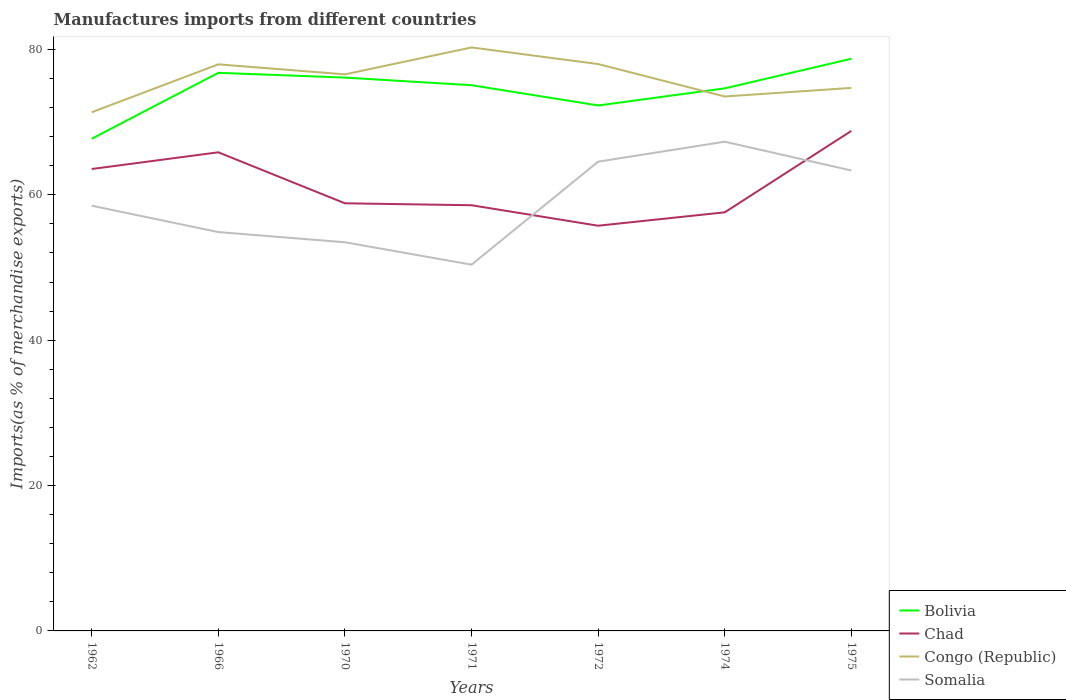Across all years, what is the maximum percentage of imports to different countries in Chad?
Offer a very short reply. 55.75. What is the total percentage of imports to different countries in Bolivia in the graph?
Make the answer very short. -2.59. What is the difference between the highest and the second highest percentage of imports to different countries in Bolivia?
Offer a terse response. 11. Is the percentage of imports to different countries in Bolivia strictly greater than the percentage of imports to different countries in Somalia over the years?
Your response must be concise. No. How many lines are there?
Offer a terse response. 4. What is the difference between two consecutive major ticks on the Y-axis?
Provide a succinct answer. 20. Does the graph contain grids?
Offer a terse response. No. Where does the legend appear in the graph?
Ensure brevity in your answer.  Bottom right. How many legend labels are there?
Make the answer very short. 4. How are the legend labels stacked?
Your answer should be compact. Vertical. What is the title of the graph?
Keep it short and to the point. Manufactures imports from different countries. Does "Cabo Verde" appear as one of the legend labels in the graph?
Provide a succinct answer. No. What is the label or title of the Y-axis?
Offer a very short reply. Imports(as % of merchandise exports). What is the Imports(as % of merchandise exports) of Bolivia in 1962?
Provide a short and direct response. 67.72. What is the Imports(as % of merchandise exports) of Chad in 1962?
Offer a very short reply. 63.55. What is the Imports(as % of merchandise exports) of Congo (Republic) in 1962?
Make the answer very short. 71.36. What is the Imports(as % of merchandise exports) of Somalia in 1962?
Give a very brief answer. 58.51. What is the Imports(as % of merchandise exports) of Bolivia in 1966?
Provide a succinct answer. 76.79. What is the Imports(as % of merchandise exports) of Chad in 1966?
Give a very brief answer. 65.85. What is the Imports(as % of merchandise exports) in Congo (Republic) in 1966?
Provide a short and direct response. 77.95. What is the Imports(as % of merchandise exports) in Somalia in 1966?
Offer a very short reply. 54.88. What is the Imports(as % of merchandise exports) in Bolivia in 1970?
Provide a short and direct response. 76.13. What is the Imports(as % of merchandise exports) of Chad in 1970?
Your response must be concise. 58.84. What is the Imports(as % of merchandise exports) in Congo (Republic) in 1970?
Your answer should be very brief. 76.58. What is the Imports(as % of merchandise exports) in Somalia in 1970?
Provide a succinct answer. 53.47. What is the Imports(as % of merchandise exports) in Bolivia in 1971?
Your answer should be compact. 75.09. What is the Imports(as % of merchandise exports) in Chad in 1971?
Give a very brief answer. 58.57. What is the Imports(as % of merchandise exports) in Congo (Republic) in 1971?
Your response must be concise. 80.28. What is the Imports(as % of merchandise exports) in Somalia in 1971?
Ensure brevity in your answer.  50.39. What is the Imports(as % of merchandise exports) in Bolivia in 1972?
Your response must be concise. 72.3. What is the Imports(as % of merchandise exports) of Chad in 1972?
Provide a succinct answer. 55.75. What is the Imports(as % of merchandise exports) of Congo (Republic) in 1972?
Your answer should be compact. 78. What is the Imports(as % of merchandise exports) of Somalia in 1972?
Provide a succinct answer. 64.56. What is the Imports(as % of merchandise exports) of Bolivia in 1974?
Provide a short and direct response. 74.65. What is the Imports(as % of merchandise exports) of Chad in 1974?
Your response must be concise. 57.59. What is the Imports(as % of merchandise exports) in Congo (Republic) in 1974?
Your answer should be compact. 73.53. What is the Imports(as % of merchandise exports) of Somalia in 1974?
Give a very brief answer. 67.31. What is the Imports(as % of merchandise exports) in Bolivia in 1975?
Your response must be concise. 78.73. What is the Imports(as % of merchandise exports) of Chad in 1975?
Your response must be concise. 68.8. What is the Imports(as % of merchandise exports) of Congo (Republic) in 1975?
Provide a succinct answer. 74.71. What is the Imports(as % of merchandise exports) in Somalia in 1975?
Your response must be concise. 63.35. Across all years, what is the maximum Imports(as % of merchandise exports) of Bolivia?
Keep it short and to the point. 78.73. Across all years, what is the maximum Imports(as % of merchandise exports) in Chad?
Your answer should be very brief. 68.8. Across all years, what is the maximum Imports(as % of merchandise exports) in Congo (Republic)?
Your answer should be compact. 80.28. Across all years, what is the maximum Imports(as % of merchandise exports) in Somalia?
Make the answer very short. 67.31. Across all years, what is the minimum Imports(as % of merchandise exports) of Bolivia?
Make the answer very short. 67.72. Across all years, what is the minimum Imports(as % of merchandise exports) of Chad?
Your answer should be compact. 55.75. Across all years, what is the minimum Imports(as % of merchandise exports) in Congo (Republic)?
Provide a short and direct response. 71.36. Across all years, what is the minimum Imports(as % of merchandise exports) in Somalia?
Provide a short and direct response. 50.39. What is the total Imports(as % of merchandise exports) of Bolivia in the graph?
Keep it short and to the point. 521.41. What is the total Imports(as % of merchandise exports) of Chad in the graph?
Give a very brief answer. 428.96. What is the total Imports(as % of merchandise exports) of Congo (Republic) in the graph?
Provide a short and direct response. 532.42. What is the total Imports(as % of merchandise exports) of Somalia in the graph?
Keep it short and to the point. 412.48. What is the difference between the Imports(as % of merchandise exports) in Bolivia in 1962 and that in 1966?
Your answer should be very brief. -9.07. What is the difference between the Imports(as % of merchandise exports) of Chad in 1962 and that in 1966?
Your answer should be compact. -2.3. What is the difference between the Imports(as % of merchandise exports) of Congo (Republic) in 1962 and that in 1966?
Your response must be concise. -6.59. What is the difference between the Imports(as % of merchandise exports) of Somalia in 1962 and that in 1966?
Keep it short and to the point. 3.63. What is the difference between the Imports(as % of merchandise exports) of Bolivia in 1962 and that in 1970?
Offer a terse response. -8.41. What is the difference between the Imports(as % of merchandise exports) in Chad in 1962 and that in 1970?
Ensure brevity in your answer.  4.72. What is the difference between the Imports(as % of merchandise exports) of Congo (Republic) in 1962 and that in 1970?
Keep it short and to the point. -5.22. What is the difference between the Imports(as % of merchandise exports) in Somalia in 1962 and that in 1970?
Ensure brevity in your answer.  5.03. What is the difference between the Imports(as % of merchandise exports) of Bolivia in 1962 and that in 1971?
Your answer should be compact. -7.36. What is the difference between the Imports(as % of merchandise exports) of Chad in 1962 and that in 1971?
Offer a very short reply. 4.98. What is the difference between the Imports(as % of merchandise exports) in Congo (Republic) in 1962 and that in 1971?
Provide a short and direct response. -8.92. What is the difference between the Imports(as % of merchandise exports) of Somalia in 1962 and that in 1971?
Offer a terse response. 8.12. What is the difference between the Imports(as % of merchandise exports) of Bolivia in 1962 and that in 1972?
Make the answer very short. -4.58. What is the difference between the Imports(as % of merchandise exports) of Chad in 1962 and that in 1972?
Your response must be concise. 7.8. What is the difference between the Imports(as % of merchandise exports) of Congo (Republic) in 1962 and that in 1972?
Your response must be concise. -6.63. What is the difference between the Imports(as % of merchandise exports) in Somalia in 1962 and that in 1972?
Your answer should be very brief. -6.06. What is the difference between the Imports(as % of merchandise exports) of Bolivia in 1962 and that in 1974?
Offer a terse response. -6.93. What is the difference between the Imports(as % of merchandise exports) in Chad in 1962 and that in 1974?
Provide a short and direct response. 5.96. What is the difference between the Imports(as % of merchandise exports) in Congo (Republic) in 1962 and that in 1974?
Your answer should be compact. -2.17. What is the difference between the Imports(as % of merchandise exports) in Somalia in 1962 and that in 1974?
Keep it short and to the point. -8.81. What is the difference between the Imports(as % of merchandise exports) of Bolivia in 1962 and that in 1975?
Keep it short and to the point. -11. What is the difference between the Imports(as % of merchandise exports) in Chad in 1962 and that in 1975?
Provide a succinct answer. -5.24. What is the difference between the Imports(as % of merchandise exports) of Congo (Republic) in 1962 and that in 1975?
Your answer should be very brief. -3.35. What is the difference between the Imports(as % of merchandise exports) of Somalia in 1962 and that in 1975?
Your answer should be very brief. -4.84. What is the difference between the Imports(as % of merchandise exports) of Bolivia in 1966 and that in 1970?
Your answer should be compact. 0.66. What is the difference between the Imports(as % of merchandise exports) in Chad in 1966 and that in 1970?
Ensure brevity in your answer.  7.02. What is the difference between the Imports(as % of merchandise exports) of Congo (Republic) in 1966 and that in 1970?
Keep it short and to the point. 1.38. What is the difference between the Imports(as % of merchandise exports) in Somalia in 1966 and that in 1970?
Ensure brevity in your answer.  1.4. What is the difference between the Imports(as % of merchandise exports) in Bolivia in 1966 and that in 1971?
Keep it short and to the point. 1.7. What is the difference between the Imports(as % of merchandise exports) of Chad in 1966 and that in 1971?
Make the answer very short. 7.28. What is the difference between the Imports(as % of merchandise exports) of Congo (Republic) in 1966 and that in 1971?
Give a very brief answer. -2.33. What is the difference between the Imports(as % of merchandise exports) of Somalia in 1966 and that in 1971?
Give a very brief answer. 4.49. What is the difference between the Imports(as % of merchandise exports) of Bolivia in 1966 and that in 1972?
Your answer should be compact. 4.49. What is the difference between the Imports(as % of merchandise exports) of Chad in 1966 and that in 1972?
Keep it short and to the point. 10.1. What is the difference between the Imports(as % of merchandise exports) in Congo (Republic) in 1966 and that in 1972?
Your answer should be compact. -0.04. What is the difference between the Imports(as % of merchandise exports) of Somalia in 1966 and that in 1972?
Your answer should be compact. -9.69. What is the difference between the Imports(as % of merchandise exports) in Bolivia in 1966 and that in 1974?
Your answer should be very brief. 2.14. What is the difference between the Imports(as % of merchandise exports) in Chad in 1966 and that in 1974?
Provide a succinct answer. 8.26. What is the difference between the Imports(as % of merchandise exports) of Congo (Republic) in 1966 and that in 1974?
Provide a succinct answer. 4.42. What is the difference between the Imports(as % of merchandise exports) in Somalia in 1966 and that in 1974?
Your answer should be compact. -12.44. What is the difference between the Imports(as % of merchandise exports) in Bolivia in 1966 and that in 1975?
Your response must be concise. -1.94. What is the difference between the Imports(as % of merchandise exports) of Chad in 1966 and that in 1975?
Provide a succinct answer. -2.94. What is the difference between the Imports(as % of merchandise exports) of Congo (Republic) in 1966 and that in 1975?
Offer a very short reply. 3.24. What is the difference between the Imports(as % of merchandise exports) in Somalia in 1966 and that in 1975?
Provide a short and direct response. -8.48. What is the difference between the Imports(as % of merchandise exports) in Bolivia in 1970 and that in 1971?
Offer a very short reply. 1.05. What is the difference between the Imports(as % of merchandise exports) in Chad in 1970 and that in 1971?
Provide a succinct answer. 0.27. What is the difference between the Imports(as % of merchandise exports) in Congo (Republic) in 1970 and that in 1971?
Keep it short and to the point. -3.7. What is the difference between the Imports(as % of merchandise exports) in Somalia in 1970 and that in 1971?
Your answer should be very brief. 3.08. What is the difference between the Imports(as % of merchandise exports) in Bolivia in 1970 and that in 1972?
Keep it short and to the point. 3.83. What is the difference between the Imports(as % of merchandise exports) in Chad in 1970 and that in 1972?
Keep it short and to the point. 3.08. What is the difference between the Imports(as % of merchandise exports) in Congo (Republic) in 1970 and that in 1972?
Make the answer very short. -1.42. What is the difference between the Imports(as % of merchandise exports) of Somalia in 1970 and that in 1972?
Your response must be concise. -11.09. What is the difference between the Imports(as % of merchandise exports) of Bolivia in 1970 and that in 1974?
Offer a terse response. 1.48. What is the difference between the Imports(as % of merchandise exports) of Chad in 1970 and that in 1974?
Give a very brief answer. 1.24. What is the difference between the Imports(as % of merchandise exports) in Congo (Republic) in 1970 and that in 1974?
Your response must be concise. 3.05. What is the difference between the Imports(as % of merchandise exports) of Somalia in 1970 and that in 1974?
Give a very brief answer. -13.84. What is the difference between the Imports(as % of merchandise exports) in Bolivia in 1970 and that in 1975?
Provide a short and direct response. -2.59. What is the difference between the Imports(as % of merchandise exports) of Chad in 1970 and that in 1975?
Offer a terse response. -9.96. What is the difference between the Imports(as % of merchandise exports) of Congo (Republic) in 1970 and that in 1975?
Provide a succinct answer. 1.86. What is the difference between the Imports(as % of merchandise exports) in Somalia in 1970 and that in 1975?
Offer a very short reply. -9.88. What is the difference between the Imports(as % of merchandise exports) in Bolivia in 1971 and that in 1972?
Make the answer very short. 2.79. What is the difference between the Imports(as % of merchandise exports) of Chad in 1971 and that in 1972?
Give a very brief answer. 2.82. What is the difference between the Imports(as % of merchandise exports) in Congo (Republic) in 1971 and that in 1972?
Provide a short and direct response. 2.29. What is the difference between the Imports(as % of merchandise exports) of Somalia in 1971 and that in 1972?
Your answer should be compact. -14.17. What is the difference between the Imports(as % of merchandise exports) in Bolivia in 1971 and that in 1974?
Make the answer very short. 0.43. What is the difference between the Imports(as % of merchandise exports) in Chad in 1971 and that in 1974?
Make the answer very short. 0.97. What is the difference between the Imports(as % of merchandise exports) in Congo (Republic) in 1971 and that in 1974?
Give a very brief answer. 6.75. What is the difference between the Imports(as % of merchandise exports) in Somalia in 1971 and that in 1974?
Your answer should be very brief. -16.92. What is the difference between the Imports(as % of merchandise exports) of Bolivia in 1971 and that in 1975?
Your answer should be compact. -3.64. What is the difference between the Imports(as % of merchandise exports) of Chad in 1971 and that in 1975?
Offer a very short reply. -10.23. What is the difference between the Imports(as % of merchandise exports) in Congo (Republic) in 1971 and that in 1975?
Offer a very short reply. 5.57. What is the difference between the Imports(as % of merchandise exports) in Somalia in 1971 and that in 1975?
Your answer should be very brief. -12.96. What is the difference between the Imports(as % of merchandise exports) in Bolivia in 1972 and that in 1974?
Ensure brevity in your answer.  -2.35. What is the difference between the Imports(as % of merchandise exports) in Chad in 1972 and that in 1974?
Provide a succinct answer. -1.84. What is the difference between the Imports(as % of merchandise exports) of Congo (Republic) in 1972 and that in 1974?
Offer a terse response. 4.46. What is the difference between the Imports(as % of merchandise exports) of Somalia in 1972 and that in 1974?
Ensure brevity in your answer.  -2.75. What is the difference between the Imports(as % of merchandise exports) of Bolivia in 1972 and that in 1975?
Ensure brevity in your answer.  -6.43. What is the difference between the Imports(as % of merchandise exports) of Chad in 1972 and that in 1975?
Offer a terse response. -13.05. What is the difference between the Imports(as % of merchandise exports) of Congo (Republic) in 1972 and that in 1975?
Your answer should be very brief. 3.28. What is the difference between the Imports(as % of merchandise exports) in Somalia in 1972 and that in 1975?
Your answer should be compact. 1.21. What is the difference between the Imports(as % of merchandise exports) of Bolivia in 1974 and that in 1975?
Provide a short and direct response. -4.07. What is the difference between the Imports(as % of merchandise exports) of Chad in 1974 and that in 1975?
Your answer should be compact. -11.2. What is the difference between the Imports(as % of merchandise exports) of Congo (Republic) in 1974 and that in 1975?
Provide a succinct answer. -1.18. What is the difference between the Imports(as % of merchandise exports) of Somalia in 1974 and that in 1975?
Ensure brevity in your answer.  3.96. What is the difference between the Imports(as % of merchandise exports) in Bolivia in 1962 and the Imports(as % of merchandise exports) in Chad in 1966?
Your answer should be compact. 1.87. What is the difference between the Imports(as % of merchandise exports) in Bolivia in 1962 and the Imports(as % of merchandise exports) in Congo (Republic) in 1966?
Provide a succinct answer. -10.23. What is the difference between the Imports(as % of merchandise exports) of Bolivia in 1962 and the Imports(as % of merchandise exports) of Somalia in 1966?
Give a very brief answer. 12.85. What is the difference between the Imports(as % of merchandise exports) of Chad in 1962 and the Imports(as % of merchandise exports) of Congo (Republic) in 1966?
Your response must be concise. -14.4. What is the difference between the Imports(as % of merchandise exports) of Chad in 1962 and the Imports(as % of merchandise exports) of Somalia in 1966?
Provide a short and direct response. 8.68. What is the difference between the Imports(as % of merchandise exports) of Congo (Republic) in 1962 and the Imports(as % of merchandise exports) of Somalia in 1966?
Make the answer very short. 16.48. What is the difference between the Imports(as % of merchandise exports) of Bolivia in 1962 and the Imports(as % of merchandise exports) of Chad in 1970?
Your answer should be compact. 8.89. What is the difference between the Imports(as % of merchandise exports) of Bolivia in 1962 and the Imports(as % of merchandise exports) of Congo (Republic) in 1970?
Ensure brevity in your answer.  -8.86. What is the difference between the Imports(as % of merchandise exports) of Bolivia in 1962 and the Imports(as % of merchandise exports) of Somalia in 1970?
Offer a very short reply. 14.25. What is the difference between the Imports(as % of merchandise exports) of Chad in 1962 and the Imports(as % of merchandise exports) of Congo (Republic) in 1970?
Offer a very short reply. -13.02. What is the difference between the Imports(as % of merchandise exports) of Chad in 1962 and the Imports(as % of merchandise exports) of Somalia in 1970?
Give a very brief answer. 10.08. What is the difference between the Imports(as % of merchandise exports) of Congo (Republic) in 1962 and the Imports(as % of merchandise exports) of Somalia in 1970?
Provide a succinct answer. 17.89. What is the difference between the Imports(as % of merchandise exports) in Bolivia in 1962 and the Imports(as % of merchandise exports) in Chad in 1971?
Your response must be concise. 9.15. What is the difference between the Imports(as % of merchandise exports) in Bolivia in 1962 and the Imports(as % of merchandise exports) in Congo (Republic) in 1971?
Give a very brief answer. -12.56. What is the difference between the Imports(as % of merchandise exports) in Bolivia in 1962 and the Imports(as % of merchandise exports) in Somalia in 1971?
Offer a terse response. 17.33. What is the difference between the Imports(as % of merchandise exports) in Chad in 1962 and the Imports(as % of merchandise exports) in Congo (Republic) in 1971?
Provide a short and direct response. -16.73. What is the difference between the Imports(as % of merchandise exports) of Chad in 1962 and the Imports(as % of merchandise exports) of Somalia in 1971?
Provide a short and direct response. 13.16. What is the difference between the Imports(as % of merchandise exports) in Congo (Republic) in 1962 and the Imports(as % of merchandise exports) in Somalia in 1971?
Provide a short and direct response. 20.97. What is the difference between the Imports(as % of merchandise exports) in Bolivia in 1962 and the Imports(as % of merchandise exports) in Chad in 1972?
Provide a short and direct response. 11.97. What is the difference between the Imports(as % of merchandise exports) of Bolivia in 1962 and the Imports(as % of merchandise exports) of Congo (Republic) in 1972?
Keep it short and to the point. -10.27. What is the difference between the Imports(as % of merchandise exports) of Bolivia in 1962 and the Imports(as % of merchandise exports) of Somalia in 1972?
Your answer should be compact. 3.16. What is the difference between the Imports(as % of merchandise exports) of Chad in 1962 and the Imports(as % of merchandise exports) of Congo (Republic) in 1972?
Offer a very short reply. -14.44. What is the difference between the Imports(as % of merchandise exports) in Chad in 1962 and the Imports(as % of merchandise exports) in Somalia in 1972?
Offer a terse response. -1.01. What is the difference between the Imports(as % of merchandise exports) in Congo (Republic) in 1962 and the Imports(as % of merchandise exports) in Somalia in 1972?
Give a very brief answer. 6.8. What is the difference between the Imports(as % of merchandise exports) of Bolivia in 1962 and the Imports(as % of merchandise exports) of Chad in 1974?
Your answer should be compact. 10.13. What is the difference between the Imports(as % of merchandise exports) of Bolivia in 1962 and the Imports(as % of merchandise exports) of Congo (Republic) in 1974?
Keep it short and to the point. -5.81. What is the difference between the Imports(as % of merchandise exports) of Bolivia in 1962 and the Imports(as % of merchandise exports) of Somalia in 1974?
Provide a short and direct response. 0.41. What is the difference between the Imports(as % of merchandise exports) of Chad in 1962 and the Imports(as % of merchandise exports) of Congo (Republic) in 1974?
Give a very brief answer. -9.98. What is the difference between the Imports(as % of merchandise exports) of Chad in 1962 and the Imports(as % of merchandise exports) of Somalia in 1974?
Keep it short and to the point. -3.76. What is the difference between the Imports(as % of merchandise exports) in Congo (Republic) in 1962 and the Imports(as % of merchandise exports) in Somalia in 1974?
Keep it short and to the point. 4.05. What is the difference between the Imports(as % of merchandise exports) in Bolivia in 1962 and the Imports(as % of merchandise exports) in Chad in 1975?
Ensure brevity in your answer.  -1.07. What is the difference between the Imports(as % of merchandise exports) of Bolivia in 1962 and the Imports(as % of merchandise exports) of Congo (Republic) in 1975?
Provide a short and direct response. -6.99. What is the difference between the Imports(as % of merchandise exports) in Bolivia in 1962 and the Imports(as % of merchandise exports) in Somalia in 1975?
Keep it short and to the point. 4.37. What is the difference between the Imports(as % of merchandise exports) in Chad in 1962 and the Imports(as % of merchandise exports) in Congo (Republic) in 1975?
Offer a terse response. -11.16. What is the difference between the Imports(as % of merchandise exports) in Chad in 1962 and the Imports(as % of merchandise exports) in Somalia in 1975?
Offer a terse response. 0.2. What is the difference between the Imports(as % of merchandise exports) in Congo (Republic) in 1962 and the Imports(as % of merchandise exports) in Somalia in 1975?
Offer a very short reply. 8.01. What is the difference between the Imports(as % of merchandise exports) of Bolivia in 1966 and the Imports(as % of merchandise exports) of Chad in 1970?
Your answer should be very brief. 17.95. What is the difference between the Imports(as % of merchandise exports) in Bolivia in 1966 and the Imports(as % of merchandise exports) in Congo (Republic) in 1970?
Your answer should be compact. 0.21. What is the difference between the Imports(as % of merchandise exports) in Bolivia in 1966 and the Imports(as % of merchandise exports) in Somalia in 1970?
Provide a short and direct response. 23.31. What is the difference between the Imports(as % of merchandise exports) of Chad in 1966 and the Imports(as % of merchandise exports) of Congo (Republic) in 1970?
Your answer should be compact. -10.72. What is the difference between the Imports(as % of merchandise exports) in Chad in 1966 and the Imports(as % of merchandise exports) in Somalia in 1970?
Offer a very short reply. 12.38. What is the difference between the Imports(as % of merchandise exports) in Congo (Republic) in 1966 and the Imports(as % of merchandise exports) in Somalia in 1970?
Offer a terse response. 24.48. What is the difference between the Imports(as % of merchandise exports) in Bolivia in 1966 and the Imports(as % of merchandise exports) in Chad in 1971?
Offer a very short reply. 18.22. What is the difference between the Imports(as % of merchandise exports) of Bolivia in 1966 and the Imports(as % of merchandise exports) of Congo (Republic) in 1971?
Your response must be concise. -3.49. What is the difference between the Imports(as % of merchandise exports) in Bolivia in 1966 and the Imports(as % of merchandise exports) in Somalia in 1971?
Give a very brief answer. 26.4. What is the difference between the Imports(as % of merchandise exports) of Chad in 1966 and the Imports(as % of merchandise exports) of Congo (Republic) in 1971?
Provide a succinct answer. -14.43. What is the difference between the Imports(as % of merchandise exports) of Chad in 1966 and the Imports(as % of merchandise exports) of Somalia in 1971?
Your response must be concise. 15.46. What is the difference between the Imports(as % of merchandise exports) of Congo (Republic) in 1966 and the Imports(as % of merchandise exports) of Somalia in 1971?
Make the answer very short. 27.56. What is the difference between the Imports(as % of merchandise exports) in Bolivia in 1966 and the Imports(as % of merchandise exports) in Chad in 1972?
Your answer should be very brief. 21.04. What is the difference between the Imports(as % of merchandise exports) in Bolivia in 1966 and the Imports(as % of merchandise exports) in Congo (Republic) in 1972?
Make the answer very short. -1.21. What is the difference between the Imports(as % of merchandise exports) of Bolivia in 1966 and the Imports(as % of merchandise exports) of Somalia in 1972?
Your answer should be compact. 12.23. What is the difference between the Imports(as % of merchandise exports) in Chad in 1966 and the Imports(as % of merchandise exports) in Congo (Republic) in 1972?
Offer a very short reply. -12.14. What is the difference between the Imports(as % of merchandise exports) of Chad in 1966 and the Imports(as % of merchandise exports) of Somalia in 1972?
Keep it short and to the point. 1.29. What is the difference between the Imports(as % of merchandise exports) in Congo (Republic) in 1966 and the Imports(as % of merchandise exports) in Somalia in 1972?
Offer a very short reply. 13.39. What is the difference between the Imports(as % of merchandise exports) in Bolivia in 1966 and the Imports(as % of merchandise exports) in Chad in 1974?
Keep it short and to the point. 19.19. What is the difference between the Imports(as % of merchandise exports) of Bolivia in 1966 and the Imports(as % of merchandise exports) of Congo (Republic) in 1974?
Offer a very short reply. 3.26. What is the difference between the Imports(as % of merchandise exports) of Bolivia in 1966 and the Imports(as % of merchandise exports) of Somalia in 1974?
Your response must be concise. 9.48. What is the difference between the Imports(as % of merchandise exports) of Chad in 1966 and the Imports(as % of merchandise exports) of Congo (Republic) in 1974?
Provide a short and direct response. -7.68. What is the difference between the Imports(as % of merchandise exports) in Chad in 1966 and the Imports(as % of merchandise exports) in Somalia in 1974?
Keep it short and to the point. -1.46. What is the difference between the Imports(as % of merchandise exports) of Congo (Republic) in 1966 and the Imports(as % of merchandise exports) of Somalia in 1974?
Offer a very short reply. 10.64. What is the difference between the Imports(as % of merchandise exports) of Bolivia in 1966 and the Imports(as % of merchandise exports) of Chad in 1975?
Give a very brief answer. 7.99. What is the difference between the Imports(as % of merchandise exports) of Bolivia in 1966 and the Imports(as % of merchandise exports) of Congo (Republic) in 1975?
Your response must be concise. 2.07. What is the difference between the Imports(as % of merchandise exports) of Bolivia in 1966 and the Imports(as % of merchandise exports) of Somalia in 1975?
Offer a very short reply. 13.44. What is the difference between the Imports(as % of merchandise exports) in Chad in 1966 and the Imports(as % of merchandise exports) in Congo (Republic) in 1975?
Provide a short and direct response. -8.86. What is the difference between the Imports(as % of merchandise exports) of Chad in 1966 and the Imports(as % of merchandise exports) of Somalia in 1975?
Offer a terse response. 2.5. What is the difference between the Imports(as % of merchandise exports) of Congo (Republic) in 1966 and the Imports(as % of merchandise exports) of Somalia in 1975?
Ensure brevity in your answer.  14.6. What is the difference between the Imports(as % of merchandise exports) in Bolivia in 1970 and the Imports(as % of merchandise exports) in Chad in 1971?
Your answer should be very brief. 17.56. What is the difference between the Imports(as % of merchandise exports) of Bolivia in 1970 and the Imports(as % of merchandise exports) of Congo (Republic) in 1971?
Offer a very short reply. -4.15. What is the difference between the Imports(as % of merchandise exports) in Bolivia in 1970 and the Imports(as % of merchandise exports) in Somalia in 1971?
Offer a very short reply. 25.74. What is the difference between the Imports(as % of merchandise exports) of Chad in 1970 and the Imports(as % of merchandise exports) of Congo (Republic) in 1971?
Keep it short and to the point. -21.45. What is the difference between the Imports(as % of merchandise exports) in Chad in 1970 and the Imports(as % of merchandise exports) in Somalia in 1971?
Your response must be concise. 8.44. What is the difference between the Imports(as % of merchandise exports) in Congo (Republic) in 1970 and the Imports(as % of merchandise exports) in Somalia in 1971?
Offer a terse response. 26.19. What is the difference between the Imports(as % of merchandise exports) in Bolivia in 1970 and the Imports(as % of merchandise exports) in Chad in 1972?
Your answer should be compact. 20.38. What is the difference between the Imports(as % of merchandise exports) of Bolivia in 1970 and the Imports(as % of merchandise exports) of Congo (Republic) in 1972?
Provide a succinct answer. -1.86. What is the difference between the Imports(as % of merchandise exports) in Bolivia in 1970 and the Imports(as % of merchandise exports) in Somalia in 1972?
Provide a succinct answer. 11.57. What is the difference between the Imports(as % of merchandise exports) of Chad in 1970 and the Imports(as % of merchandise exports) of Congo (Republic) in 1972?
Your response must be concise. -19.16. What is the difference between the Imports(as % of merchandise exports) of Chad in 1970 and the Imports(as % of merchandise exports) of Somalia in 1972?
Offer a terse response. -5.73. What is the difference between the Imports(as % of merchandise exports) of Congo (Republic) in 1970 and the Imports(as % of merchandise exports) of Somalia in 1972?
Give a very brief answer. 12.02. What is the difference between the Imports(as % of merchandise exports) of Bolivia in 1970 and the Imports(as % of merchandise exports) of Chad in 1974?
Provide a short and direct response. 18.54. What is the difference between the Imports(as % of merchandise exports) in Bolivia in 1970 and the Imports(as % of merchandise exports) in Congo (Republic) in 1974?
Provide a succinct answer. 2.6. What is the difference between the Imports(as % of merchandise exports) of Bolivia in 1970 and the Imports(as % of merchandise exports) of Somalia in 1974?
Your answer should be compact. 8.82. What is the difference between the Imports(as % of merchandise exports) in Chad in 1970 and the Imports(as % of merchandise exports) in Congo (Republic) in 1974?
Offer a very short reply. -14.7. What is the difference between the Imports(as % of merchandise exports) in Chad in 1970 and the Imports(as % of merchandise exports) in Somalia in 1974?
Give a very brief answer. -8.48. What is the difference between the Imports(as % of merchandise exports) in Congo (Republic) in 1970 and the Imports(as % of merchandise exports) in Somalia in 1974?
Offer a very short reply. 9.26. What is the difference between the Imports(as % of merchandise exports) in Bolivia in 1970 and the Imports(as % of merchandise exports) in Chad in 1975?
Keep it short and to the point. 7.33. What is the difference between the Imports(as % of merchandise exports) of Bolivia in 1970 and the Imports(as % of merchandise exports) of Congo (Republic) in 1975?
Make the answer very short. 1.42. What is the difference between the Imports(as % of merchandise exports) in Bolivia in 1970 and the Imports(as % of merchandise exports) in Somalia in 1975?
Provide a succinct answer. 12.78. What is the difference between the Imports(as % of merchandise exports) of Chad in 1970 and the Imports(as % of merchandise exports) of Congo (Republic) in 1975?
Provide a succinct answer. -15.88. What is the difference between the Imports(as % of merchandise exports) of Chad in 1970 and the Imports(as % of merchandise exports) of Somalia in 1975?
Make the answer very short. -4.52. What is the difference between the Imports(as % of merchandise exports) of Congo (Republic) in 1970 and the Imports(as % of merchandise exports) of Somalia in 1975?
Your answer should be compact. 13.23. What is the difference between the Imports(as % of merchandise exports) of Bolivia in 1971 and the Imports(as % of merchandise exports) of Chad in 1972?
Keep it short and to the point. 19.33. What is the difference between the Imports(as % of merchandise exports) of Bolivia in 1971 and the Imports(as % of merchandise exports) of Congo (Republic) in 1972?
Give a very brief answer. -2.91. What is the difference between the Imports(as % of merchandise exports) of Bolivia in 1971 and the Imports(as % of merchandise exports) of Somalia in 1972?
Provide a succinct answer. 10.52. What is the difference between the Imports(as % of merchandise exports) in Chad in 1971 and the Imports(as % of merchandise exports) in Congo (Republic) in 1972?
Give a very brief answer. -19.43. What is the difference between the Imports(as % of merchandise exports) of Chad in 1971 and the Imports(as % of merchandise exports) of Somalia in 1972?
Make the answer very short. -5.99. What is the difference between the Imports(as % of merchandise exports) in Congo (Republic) in 1971 and the Imports(as % of merchandise exports) in Somalia in 1972?
Offer a very short reply. 15.72. What is the difference between the Imports(as % of merchandise exports) of Bolivia in 1971 and the Imports(as % of merchandise exports) of Chad in 1974?
Offer a very short reply. 17.49. What is the difference between the Imports(as % of merchandise exports) of Bolivia in 1971 and the Imports(as % of merchandise exports) of Congo (Republic) in 1974?
Give a very brief answer. 1.55. What is the difference between the Imports(as % of merchandise exports) of Bolivia in 1971 and the Imports(as % of merchandise exports) of Somalia in 1974?
Give a very brief answer. 7.77. What is the difference between the Imports(as % of merchandise exports) of Chad in 1971 and the Imports(as % of merchandise exports) of Congo (Republic) in 1974?
Your answer should be very brief. -14.96. What is the difference between the Imports(as % of merchandise exports) in Chad in 1971 and the Imports(as % of merchandise exports) in Somalia in 1974?
Your answer should be very brief. -8.74. What is the difference between the Imports(as % of merchandise exports) of Congo (Republic) in 1971 and the Imports(as % of merchandise exports) of Somalia in 1974?
Give a very brief answer. 12.97. What is the difference between the Imports(as % of merchandise exports) of Bolivia in 1971 and the Imports(as % of merchandise exports) of Chad in 1975?
Give a very brief answer. 6.29. What is the difference between the Imports(as % of merchandise exports) of Bolivia in 1971 and the Imports(as % of merchandise exports) of Congo (Republic) in 1975?
Offer a very short reply. 0.37. What is the difference between the Imports(as % of merchandise exports) in Bolivia in 1971 and the Imports(as % of merchandise exports) in Somalia in 1975?
Provide a succinct answer. 11.73. What is the difference between the Imports(as % of merchandise exports) in Chad in 1971 and the Imports(as % of merchandise exports) in Congo (Republic) in 1975?
Offer a terse response. -16.14. What is the difference between the Imports(as % of merchandise exports) in Chad in 1971 and the Imports(as % of merchandise exports) in Somalia in 1975?
Offer a terse response. -4.78. What is the difference between the Imports(as % of merchandise exports) of Congo (Republic) in 1971 and the Imports(as % of merchandise exports) of Somalia in 1975?
Ensure brevity in your answer.  16.93. What is the difference between the Imports(as % of merchandise exports) in Bolivia in 1972 and the Imports(as % of merchandise exports) in Chad in 1974?
Your answer should be very brief. 14.7. What is the difference between the Imports(as % of merchandise exports) of Bolivia in 1972 and the Imports(as % of merchandise exports) of Congo (Republic) in 1974?
Provide a succinct answer. -1.23. What is the difference between the Imports(as % of merchandise exports) of Bolivia in 1972 and the Imports(as % of merchandise exports) of Somalia in 1974?
Provide a succinct answer. 4.99. What is the difference between the Imports(as % of merchandise exports) of Chad in 1972 and the Imports(as % of merchandise exports) of Congo (Republic) in 1974?
Provide a short and direct response. -17.78. What is the difference between the Imports(as % of merchandise exports) in Chad in 1972 and the Imports(as % of merchandise exports) in Somalia in 1974?
Your answer should be compact. -11.56. What is the difference between the Imports(as % of merchandise exports) in Congo (Republic) in 1972 and the Imports(as % of merchandise exports) in Somalia in 1974?
Provide a succinct answer. 10.68. What is the difference between the Imports(as % of merchandise exports) of Bolivia in 1972 and the Imports(as % of merchandise exports) of Chad in 1975?
Offer a terse response. 3.5. What is the difference between the Imports(as % of merchandise exports) in Bolivia in 1972 and the Imports(as % of merchandise exports) in Congo (Republic) in 1975?
Your answer should be compact. -2.42. What is the difference between the Imports(as % of merchandise exports) in Bolivia in 1972 and the Imports(as % of merchandise exports) in Somalia in 1975?
Give a very brief answer. 8.95. What is the difference between the Imports(as % of merchandise exports) of Chad in 1972 and the Imports(as % of merchandise exports) of Congo (Republic) in 1975?
Ensure brevity in your answer.  -18.96. What is the difference between the Imports(as % of merchandise exports) in Chad in 1972 and the Imports(as % of merchandise exports) in Somalia in 1975?
Offer a very short reply. -7.6. What is the difference between the Imports(as % of merchandise exports) in Congo (Republic) in 1972 and the Imports(as % of merchandise exports) in Somalia in 1975?
Keep it short and to the point. 14.64. What is the difference between the Imports(as % of merchandise exports) of Bolivia in 1974 and the Imports(as % of merchandise exports) of Chad in 1975?
Offer a very short reply. 5.86. What is the difference between the Imports(as % of merchandise exports) of Bolivia in 1974 and the Imports(as % of merchandise exports) of Congo (Republic) in 1975?
Your answer should be very brief. -0.06. What is the difference between the Imports(as % of merchandise exports) in Bolivia in 1974 and the Imports(as % of merchandise exports) in Somalia in 1975?
Provide a short and direct response. 11.3. What is the difference between the Imports(as % of merchandise exports) in Chad in 1974 and the Imports(as % of merchandise exports) in Congo (Republic) in 1975?
Offer a terse response. -17.12. What is the difference between the Imports(as % of merchandise exports) in Chad in 1974 and the Imports(as % of merchandise exports) in Somalia in 1975?
Ensure brevity in your answer.  -5.76. What is the difference between the Imports(as % of merchandise exports) of Congo (Republic) in 1974 and the Imports(as % of merchandise exports) of Somalia in 1975?
Provide a succinct answer. 10.18. What is the average Imports(as % of merchandise exports) of Bolivia per year?
Give a very brief answer. 74.49. What is the average Imports(as % of merchandise exports) in Chad per year?
Your response must be concise. 61.28. What is the average Imports(as % of merchandise exports) of Congo (Republic) per year?
Your answer should be very brief. 76.06. What is the average Imports(as % of merchandise exports) in Somalia per year?
Provide a short and direct response. 58.93. In the year 1962, what is the difference between the Imports(as % of merchandise exports) of Bolivia and Imports(as % of merchandise exports) of Chad?
Ensure brevity in your answer.  4.17. In the year 1962, what is the difference between the Imports(as % of merchandise exports) in Bolivia and Imports(as % of merchandise exports) in Congo (Republic)?
Give a very brief answer. -3.64. In the year 1962, what is the difference between the Imports(as % of merchandise exports) in Bolivia and Imports(as % of merchandise exports) in Somalia?
Your answer should be very brief. 9.21. In the year 1962, what is the difference between the Imports(as % of merchandise exports) of Chad and Imports(as % of merchandise exports) of Congo (Republic)?
Make the answer very short. -7.81. In the year 1962, what is the difference between the Imports(as % of merchandise exports) of Chad and Imports(as % of merchandise exports) of Somalia?
Your answer should be compact. 5.05. In the year 1962, what is the difference between the Imports(as % of merchandise exports) of Congo (Republic) and Imports(as % of merchandise exports) of Somalia?
Your answer should be compact. 12.85. In the year 1966, what is the difference between the Imports(as % of merchandise exports) in Bolivia and Imports(as % of merchandise exports) in Chad?
Your answer should be compact. 10.94. In the year 1966, what is the difference between the Imports(as % of merchandise exports) of Bolivia and Imports(as % of merchandise exports) of Congo (Republic)?
Give a very brief answer. -1.17. In the year 1966, what is the difference between the Imports(as % of merchandise exports) of Bolivia and Imports(as % of merchandise exports) of Somalia?
Offer a very short reply. 21.91. In the year 1966, what is the difference between the Imports(as % of merchandise exports) of Chad and Imports(as % of merchandise exports) of Congo (Republic)?
Your answer should be very brief. -12.1. In the year 1966, what is the difference between the Imports(as % of merchandise exports) of Chad and Imports(as % of merchandise exports) of Somalia?
Make the answer very short. 10.98. In the year 1966, what is the difference between the Imports(as % of merchandise exports) in Congo (Republic) and Imports(as % of merchandise exports) in Somalia?
Make the answer very short. 23.08. In the year 1970, what is the difference between the Imports(as % of merchandise exports) in Bolivia and Imports(as % of merchandise exports) in Chad?
Ensure brevity in your answer.  17.3. In the year 1970, what is the difference between the Imports(as % of merchandise exports) of Bolivia and Imports(as % of merchandise exports) of Congo (Republic)?
Provide a short and direct response. -0.45. In the year 1970, what is the difference between the Imports(as % of merchandise exports) in Bolivia and Imports(as % of merchandise exports) in Somalia?
Offer a terse response. 22.66. In the year 1970, what is the difference between the Imports(as % of merchandise exports) in Chad and Imports(as % of merchandise exports) in Congo (Republic)?
Provide a succinct answer. -17.74. In the year 1970, what is the difference between the Imports(as % of merchandise exports) of Chad and Imports(as % of merchandise exports) of Somalia?
Your response must be concise. 5.36. In the year 1970, what is the difference between the Imports(as % of merchandise exports) of Congo (Republic) and Imports(as % of merchandise exports) of Somalia?
Give a very brief answer. 23.1. In the year 1971, what is the difference between the Imports(as % of merchandise exports) in Bolivia and Imports(as % of merchandise exports) in Chad?
Your response must be concise. 16.52. In the year 1971, what is the difference between the Imports(as % of merchandise exports) of Bolivia and Imports(as % of merchandise exports) of Congo (Republic)?
Offer a very short reply. -5.2. In the year 1971, what is the difference between the Imports(as % of merchandise exports) in Bolivia and Imports(as % of merchandise exports) in Somalia?
Your answer should be very brief. 24.69. In the year 1971, what is the difference between the Imports(as % of merchandise exports) of Chad and Imports(as % of merchandise exports) of Congo (Republic)?
Make the answer very short. -21.71. In the year 1971, what is the difference between the Imports(as % of merchandise exports) in Chad and Imports(as % of merchandise exports) in Somalia?
Give a very brief answer. 8.18. In the year 1971, what is the difference between the Imports(as % of merchandise exports) in Congo (Republic) and Imports(as % of merchandise exports) in Somalia?
Provide a short and direct response. 29.89. In the year 1972, what is the difference between the Imports(as % of merchandise exports) in Bolivia and Imports(as % of merchandise exports) in Chad?
Provide a succinct answer. 16.55. In the year 1972, what is the difference between the Imports(as % of merchandise exports) in Bolivia and Imports(as % of merchandise exports) in Congo (Republic)?
Provide a short and direct response. -5.7. In the year 1972, what is the difference between the Imports(as % of merchandise exports) of Bolivia and Imports(as % of merchandise exports) of Somalia?
Keep it short and to the point. 7.74. In the year 1972, what is the difference between the Imports(as % of merchandise exports) in Chad and Imports(as % of merchandise exports) in Congo (Republic)?
Make the answer very short. -22.24. In the year 1972, what is the difference between the Imports(as % of merchandise exports) of Chad and Imports(as % of merchandise exports) of Somalia?
Make the answer very short. -8.81. In the year 1972, what is the difference between the Imports(as % of merchandise exports) of Congo (Republic) and Imports(as % of merchandise exports) of Somalia?
Keep it short and to the point. 13.43. In the year 1974, what is the difference between the Imports(as % of merchandise exports) in Bolivia and Imports(as % of merchandise exports) in Chad?
Your answer should be compact. 17.06. In the year 1974, what is the difference between the Imports(as % of merchandise exports) in Bolivia and Imports(as % of merchandise exports) in Congo (Republic)?
Give a very brief answer. 1.12. In the year 1974, what is the difference between the Imports(as % of merchandise exports) in Bolivia and Imports(as % of merchandise exports) in Somalia?
Ensure brevity in your answer.  7.34. In the year 1974, what is the difference between the Imports(as % of merchandise exports) in Chad and Imports(as % of merchandise exports) in Congo (Republic)?
Your answer should be compact. -15.94. In the year 1974, what is the difference between the Imports(as % of merchandise exports) in Chad and Imports(as % of merchandise exports) in Somalia?
Offer a very short reply. -9.72. In the year 1974, what is the difference between the Imports(as % of merchandise exports) in Congo (Republic) and Imports(as % of merchandise exports) in Somalia?
Provide a succinct answer. 6.22. In the year 1975, what is the difference between the Imports(as % of merchandise exports) in Bolivia and Imports(as % of merchandise exports) in Chad?
Give a very brief answer. 9.93. In the year 1975, what is the difference between the Imports(as % of merchandise exports) in Bolivia and Imports(as % of merchandise exports) in Congo (Republic)?
Ensure brevity in your answer.  4.01. In the year 1975, what is the difference between the Imports(as % of merchandise exports) of Bolivia and Imports(as % of merchandise exports) of Somalia?
Your answer should be very brief. 15.37. In the year 1975, what is the difference between the Imports(as % of merchandise exports) of Chad and Imports(as % of merchandise exports) of Congo (Republic)?
Ensure brevity in your answer.  -5.92. In the year 1975, what is the difference between the Imports(as % of merchandise exports) of Chad and Imports(as % of merchandise exports) of Somalia?
Provide a short and direct response. 5.44. In the year 1975, what is the difference between the Imports(as % of merchandise exports) in Congo (Republic) and Imports(as % of merchandise exports) in Somalia?
Your response must be concise. 11.36. What is the ratio of the Imports(as % of merchandise exports) of Bolivia in 1962 to that in 1966?
Ensure brevity in your answer.  0.88. What is the ratio of the Imports(as % of merchandise exports) of Chad in 1962 to that in 1966?
Your response must be concise. 0.97. What is the ratio of the Imports(as % of merchandise exports) in Congo (Republic) in 1962 to that in 1966?
Provide a short and direct response. 0.92. What is the ratio of the Imports(as % of merchandise exports) of Somalia in 1962 to that in 1966?
Your answer should be very brief. 1.07. What is the ratio of the Imports(as % of merchandise exports) in Bolivia in 1962 to that in 1970?
Offer a very short reply. 0.89. What is the ratio of the Imports(as % of merchandise exports) in Chad in 1962 to that in 1970?
Your answer should be compact. 1.08. What is the ratio of the Imports(as % of merchandise exports) of Congo (Republic) in 1962 to that in 1970?
Your answer should be compact. 0.93. What is the ratio of the Imports(as % of merchandise exports) of Somalia in 1962 to that in 1970?
Provide a succinct answer. 1.09. What is the ratio of the Imports(as % of merchandise exports) of Bolivia in 1962 to that in 1971?
Your response must be concise. 0.9. What is the ratio of the Imports(as % of merchandise exports) in Chad in 1962 to that in 1971?
Provide a succinct answer. 1.09. What is the ratio of the Imports(as % of merchandise exports) of Somalia in 1962 to that in 1971?
Make the answer very short. 1.16. What is the ratio of the Imports(as % of merchandise exports) of Bolivia in 1962 to that in 1972?
Ensure brevity in your answer.  0.94. What is the ratio of the Imports(as % of merchandise exports) of Chad in 1962 to that in 1972?
Provide a succinct answer. 1.14. What is the ratio of the Imports(as % of merchandise exports) of Congo (Republic) in 1962 to that in 1972?
Ensure brevity in your answer.  0.92. What is the ratio of the Imports(as % of merchandise exports) in Somalia in 1962 to that in 1972?
Ensure brevity in your answer.  0.91. What is the ratio of the Imports(as % of merchandise exports) in Bolivia in 1962 to that in 1974?
Your answer should be compact. 0.91. What is the ratio of the Imports(as % of merchandise exports) in Chad in 1962 to that in 1974?
Offer a very short reply. 1.1. What is the ratio of the Imports(as % of merchandise exports) in Congo (Republic) in 1962 to that in 1974?
Ensure brevity in your answer.  0.97. What is the ratio of the Imports(as % of merchandise exports) in Somalia in 1962 to that in 1974?
Offer a very short reply. 0.87. What is the ratio of the Imports(as % of merchandise exports) of Bolivia in 1962 to that in 1975?
Provide a short and direct response. 0.86. What is the ratio of the Imports(as % of merchandise exports) of Chad in 1962 to that in 1975?
Offer a terse response. 0.92. What is the ratio of the Imports(as % of merchandise exports) in Congo (Republic) in 1962 to that in 1975?
Give a very brief answer. 0.96. What is the ratio of the Imports(as % of merchandise exports) of Somalia in 1962 to that in 1975?
Make the answer very short. 0.92. What is the ratio of the Imports(as % of merchandise exports) of Bolivia in 1966 to that in 1970?
Give a very brief answer. 1.01. What is the ratio of the Imports(as % of merchandise exports) of Chad in 1966 to that in 1970?
Ensure brevity in your answer.  1.12. What is the ratio of the Imports(as % of merchandise exports) of Congo (Republic) in 1966 to that in 1970?
Provide a short and direct response. 1.02. What is the ratio of the Imports(as % of merchandise exports) of Somalia in 1966 to that in 1970?
Ensure brevity in your answer.  1.03. What is the ratio of the Imports(as % of merchandise exports) of Bolivia in 1966 to that in 1971?
Your answer should be compact. 1.02. What is the ratio of the Imports(as % of merchandise exports) of Chad in 1966 to that in 1971?
Ensure brevity in your answer.  1.12. What is the ratio of the Imports(as % of merchandise exports) in Congo (Republic) in 1966 to that in 1971?
Provide a succinct answer. 0.97. What is the ratio of the Imports(as % of merchandise exports) in Somalia in 1966 to that in 1971?
Provide a succinct answer. 1.09. What is the ratio of the Imports(as % of merchandise exports) in Bolivia in 1966 to that in 1972?
Make the answer very short. 1.06. What is the ratio of the Imports(as % of merchandise exports) of Chad in 1966 to that in 1972?
Your answer should be compact. 1.18. What is the ratio of the Imports(as % of merchandise exports) in Somalia in 1966 to that in 1972?
Your answer should be very brief. 0.85. What is the ratio of the Imports(as % of merchandise exports) of Bolivia in 1966 to that in 1974?
Offer a very short reply. 1.03. What is the ratio of the Imports(as % of merchandise exports) in Chad in 1966 to that in 1974?
Your response must be concise. 1.14. What is the ratio of the Imports(as % of merchandise exports) in Congo (Republic) in 1966 to that in 1974?
Your answer should be very brief. 1.06. What is the ratio of the Imports(as % of merchandise exports) of Somalia in 1966 to that in 1974?
Keep it short and to the point. 0.82. What is the ratio of the Imports(as % of merchandise exports) in Bolivia in 1966 to that in 1975?
Provide a succinct answer. 0.98. What is the ratio of the Imports(as % of merchandise exports) of Chad in 1966 to that in 1975?
Provide a succinct answer. 0.96. What is the ratio of the Imports(as % of merchandise exports) of Congo (Republic) in 1966 to that in 1975?
Keep it short and to the point. 1.04. What is the ratio of the Imports(as % of merchandise exports) in Somalia in 1966 to that in 1975?
Keep it short and to the point. 0.87. What is the ratio of the Imports(as % of merchandise exports) in Bolivia in 1970 to that in 1971?
Offer a very short reply. 1.01. What is the ratio of the Imports(as % of merchandise exports) of Congo (Republic) in 1970 to that in 1971?
Provide a short and direct response. 0.95. What is the ratio of the Imports(as % of merchandise exports) of Somalia in 1970 to that in 1971?
Make the answer very short. 1.06. What is the ratio of the Imports(as % of merchandise exports) in Bolivia in 1970 to that in 1972?
Offer a terse response. 1.05. What is the ratio of the Imports(as % of merchandise exports) of Chad in 1970 to that in 1972?
Make the answer very short. 1.06. What is the ratio of the Imports(as % of merchandise exports) of Congo (Republic) in 1970 to that in 1972?
Make the answer very short. 0.98. What is the ratio of the Imports(as % of merchandise exports) of Somalia in 1970 to that in 1972?
Your response must be concise. 0.83. What is the ratio of the Imports(as % of merchandise exports) in Bolivia in 1970 to that in 1974?
Give a very brief answer. 1.02. What is the ratio of the Imports(as % of merchandise exports) of Chad in 1970 to that in 1974?
Provide a succinct answer. 1.02. What is the ratio of the Imports(as % of merchandise exports) in Congo (Republic) in 1970 to that in 1974?
Offer a terse response. 1.04. What is the ratio of the Imports(as % of merchandise exports) in Somalia in 1970 to that in 1974?
Provide a short and direct response. 0.79. What is the ratio of the Imports(as % of merchandise exports) of Bolivia in 1970 to that in 1975?
Ensure brevity in your answer.  0.97. What is the ratio of the Imports(as % of merchandise exports) in Chad in 1970 to that in 1975?
Your answer should be very brief. 0.86. What is the ratio of the Imports(as % of merchandise exports) in Congo (Republic) in 1970 to that in 1975?
Offer a very short reply. 1.02. What is the ratio of the Imports(as % of merchandise exports) in Somalia in 1970 to that in 1975?
Ensure brevity in your answer.  0.84. What is the ratio of the Imports(as % of merchandise exports) in Bolivia in 1971 to that in 1972?
Provide a short and direct response. 1.04. What is the ratio of the Imports(as % of merchandise exports) in Chad in 1971 to that in 1972?
Offer a terse response. 1.05. What is the ratio of the Imports(as % of merchandise exports) of Congo (Republic) in 1971 to that in 1972?
Ensure brevity in your answer.  1.03. What is the ratio of the Imports(as % of merchandise exports) of Somalia in 1971 to that in 1972?
Your answer should be very brief. 0.78. What is the ratio of the Imports(as % of merchandise exports) of Chad in 1971 to that in 1974?
Provide a short and direct response. 1.02. What is the ratio of the Imports(as % of merchandise exports) of Congo (Republic) in 1971 to that in 1974?
Offer a terse response. 1.09. What is the ratio of the Imports(as % of merchandise exports) of Somalia in 1971 to that in 1974?
Provide a short and direct response. 0.75. What is the ratio of the Imports(as % of merchandise exports) in Bolivia in 1971 to that in 1975?
Make the answer very short. 0.95. What is the ratio of the Imports(as % of merchandise exports) of Chad in 1971 to that in 1975?
Make the answer very short. 0.85. What is the ratio of the Imports(as % of merchandise exports) in Congo (Republic) in 1971 to that in 1975?
Ensure brevity in your answer.  1.07. What is the ratio of the Imports(as % of merchandise exports) of Somalia in 1971 to that in 1975?
Provide a short and direct response. 0.8. What is the ratio of the Imports(as % of merchandise exports) in Bolivia in 1972 to that in 1974?
Offer a very short reply. 0.97. What is the ratio of the Imports(as % of merchandise exports) of Chad in 1972 to that in 1974?
Ensure brevity in your answer.  0.97. What is the ratio of the Imports(as % of merchandise exports) in Congo (Republic) in 1972 to that in 1974?
Your answer should be very brief. 1.06. What is the ratio of the Imports(as % of merchandise exports) of Somalia in 1972 to that in 1974?
Your response must be concise. 0.96. What is the ratio of the Imports(as % of merchandise exports) of Bolivia in 1972 to that in 1975?
Your response must be concise. 0.92. What is the ratio of the Imports(as % of merchandise exports) of Chad in 1972 to that in 1975?
Provide a succinct answer. 0.81. What is the ratio of the Imports(as % of merchandise exports) of Congo (Republic) in 1972 to that in 1975?
Offer a very short reply. 1.04. What is the ratio of the Imports(as % of merchandise exports) of Somalia in 1972 to that in 1975?
Keep it short and to the point. 1.02. What is the ratio of the Imports(as % of merchandise exports) of Bolivia in 1974 to that in 1975?
Keep it short and to the point. 0.95. What is the ratio of the Imports(as % of merchandise exports) in Chad in 1974 to that in 1975?
Provide a succinct answer. 0.84. What is the ratio of the Imports(as % of merchandise exports) in Congo (Republic) in 1974 to that in 1975?
Your answer should be very brief. 0.98. What is the ratio of the Imports(as % of merchandise exports) of Somalia in 1974 to that in 1975?
Provide a short and direct response. 1.06. What is the difference between the highest and the second highest Imports(as % of merchandise exports) of Bolivia?
Your response must be concise. 1.94. What is the difference between the highest and the second highest Imports(as % of merchandise exports) of Chad?
Provide a short and direct response. 2.94. What is the difference between the highest and the second highest Imports(as % of merchandise exports) of Congo (Republic)?
Your response must be concise. 2.29. What is the difference between the highest and the second highest Imports(as % of merchandise exports) in Somalia?
Provide a succinct answer. 2.75. What is the difference between the highest and the lowest Imports(as % of merchandise exports) in Bolivia?
Ensure brevity in your answer.  11. What is the difference between the highest and the lowest Imports(as % of merchandise exports) of Chad?
Ensure brevity in your answer.  13.05. What is the difference between the highest and the lowest Imports(as % of merchandise exports) of Congo (Republic)?
Offer a terse response. 8.92. What is the difference between the highest and the lowest Imports(as % of merchandise exports) in Somalia?
Make the answer very short. 16.92. 